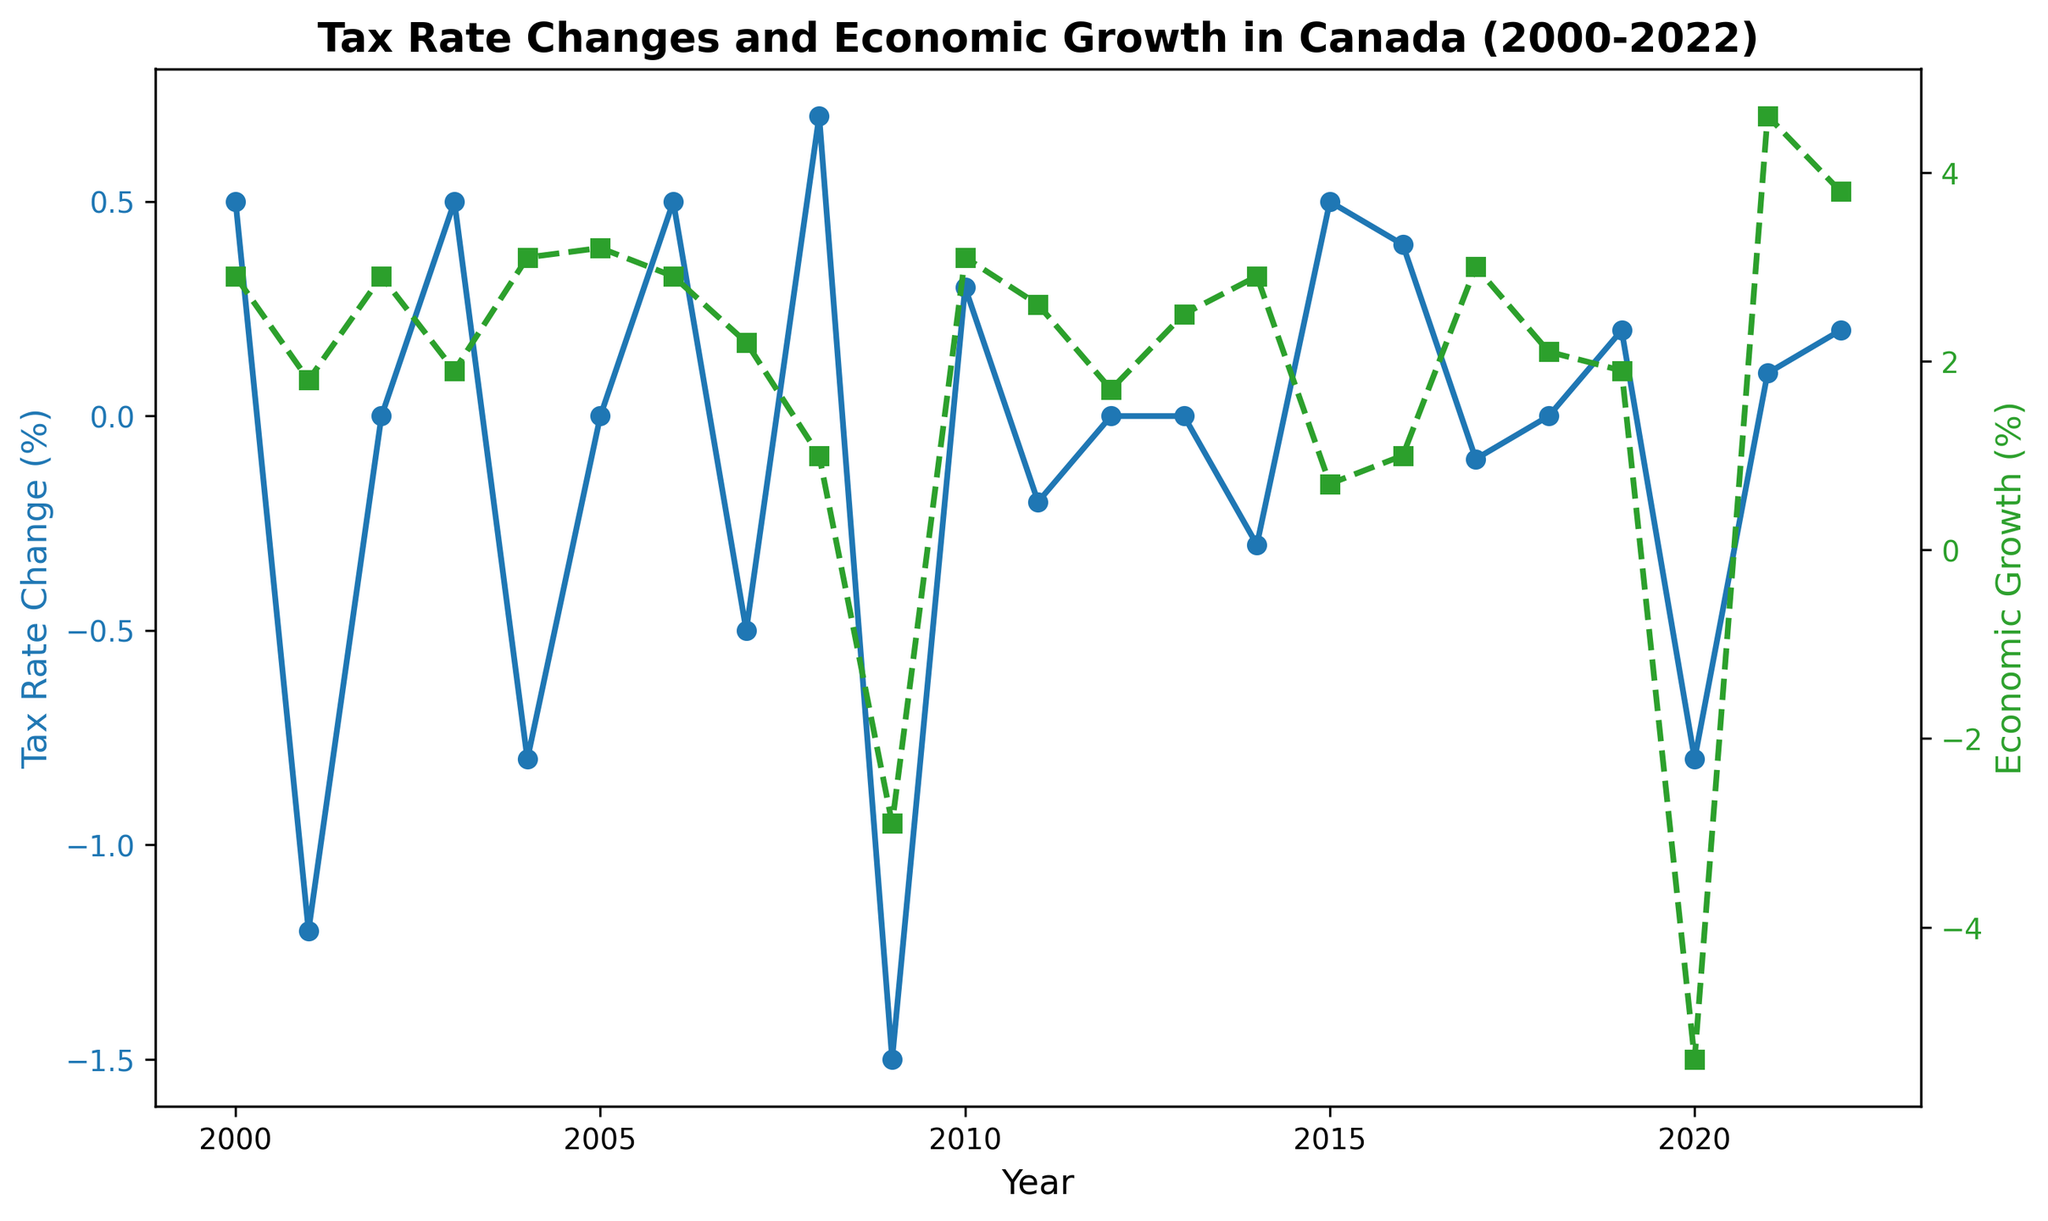What years had negative tax rate changes? To find the years with negative tax rate changes, look for the blue line (Tax Rate Change) dropping below the horizontal axis. Identify the corresponding years on the x-axis.
Answer: 2001, 2004, 2007, 2009, 2011, 2014, 2017, 2020 In which year did the economic growth rate hit its lowest point? Locate the green dashed line (Economic Growth) and identify the lowest point. Then, find the corresponding year on the x-axis.
Answer: 2020 What is the difference in economic growth between 2001 and 2021? Read the economic growth values for 2001 (1.8%) and 2021 (4.6%). Subtract the earlier value from the later one: 4.6% - 1.8%
Answer: 2.8% During which years did both the tax rate change and economic growth remain stagnant (0%)? Look for years where both lines intersect the horizontal axis with no upward or downward movement. Check for these conditions on both axes.
Answer: 2002, 2005, 2012, 2013, 2018 How many times did the tax rate change increase while the economic growth rate decreased? Identify the years where the blue line is moving upward while the green dashed line is moving downward: 2003, 2008, 2015, 2016, 2019. Count these occurrences.
Answer: 5 times Which year had the highest positive tax rate change and what was the corresponding economic growth rate? Identify the peak of the blue line (Tax Rate Change) to find the highest positive tax rate change then find the corresponding point of the green dashed line (Economic Growth).
Answer: 2008 (Tax Rate Change = 0.7), (Economic Growth = 1.0) What was the average economic growth rate from 2000 to 2022? Add the values of economic growth from 2000 to 2022 and divide by the number of years (23). Mean = sum / count
Answer: 2.0% 